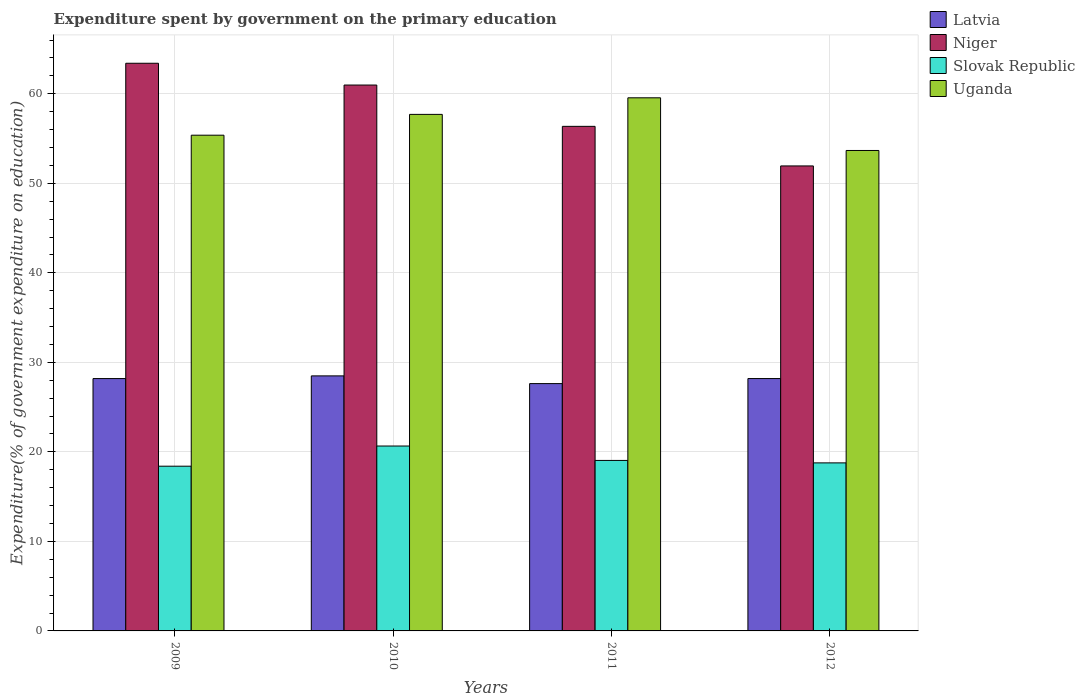How many groups of bars are there?
Give a very brief answer. 4. Are the number of bars per tick equal to the number of legend labels?
Your answer should be compact. Yes. Are the number of bars on each tick of the X-axis equal?
Your answer should be compact. Yes. How many bars are there on the 2nd tick from the left?
Offer a terse response. 4. What is the expenditure spent by government on the primary education in Niger in 2010?
Give a very brief answer. 60.98. Across all years, what is the maximum expenditure spent by government on the primary education in Latvia?
Give a very brief answer. 28.49. Across all years, what is the minimum expenditure spent by government on the primary education in Uganda?
Your response must be concise. 53.67. In which year was the expenditure spent by government on the primary education in Latvia maximum?
Keep it short and to the point. 2010. In which year was the expenditure spent by government on the primary education in Slovak Republic minimum?
Ensure brevity in your answer.  2009. What is the total expenditure spent by government on the primary education in Niger in the graph?
Your answer should be compact. 232.69. What is the difference between the expenditure spent by government on the primary education in Slovak Republic in 2011 and that in 2012?
Offer a terse response. 0.27. What is the difference between the expenditure spent by government on the primary education in Uganda in 2011 and the expenditure spent by government on the primary education in Latvia in 2009?
Provide a succinct answer. 31.36. What is the average expenditure spent by government on the primary education in Niger per year?
Your answer should be compact. 58.17. In the year 2010, what is the difference between the expenditure spent by government on the primary education in Uganda and expenditure spent by government on the primary education in Niger?
Your answer should be very brief. -3.28. What is the ratio of the expenditure spent by government on the primary education in Niger in 2009 to that in 2010?
Provide a short and direct response. 1.04. Is the difference between the expenditure spent by government on the primary education in Uganda in 2009 and 2011 greater than the difference between the expenditure spent by government on the primary education in Niger in 2009 and 2011?
Make the answer very short. No. What is the difference between the highest and the second highest expenditure spent by government on the primary education in Latvia?
Your answer should be very brief. 0.3. What is the difference between the highest and the lowest expenditure spent by government on the primary education in Niger?
Provide a short and direct response. 11.47. In how many years, is the expenditure spent by government on the primary education in Niger greater than the average expenditure spent by government on the primary education in Niger taken over all years?
Provide a short and direct response. 2. Is the sum of the expenditure spent by government on the primary education in Latvia in 2009 and 2012 greater than the maximum expenditure spent by government on the primary education in Uganda across all years?
Make the answer very short. No. What does the 3rd bar from the left in 2010 represents?
Ensure brevity in your answer.  Slovak Republic. What does the 3rd bar from the right in 2009 represents?
Ensure brevity in your answer.  Niger. How many bars are there?
Your answer should be very brief. 16. How many years are there in the graph?
Your answer should be very brief. 4. Are the values on the major ticks of Y-axis written in scientific E-notation?
Offer a very short reply. No. Where does the legend appear in the graph?
Make the answer very short. Top right. How many legend labels are there?
Offer a very short reply. 4. How are the legend labels stacked?
Your answer should be very brief. Vertical. What is the title of the graph?
Provide a short and direct response. Expenditure spent by government on the primary education. What is the label or title of the Y-axis?
Your response must be concise. Expenditure(% of government expenditure on education). What is the Expenditure(% of government expenditure on education) of Latvia in 2009?
Make the answer very short. 28.19. What is the Expenditure(% of government expenditure on education) in Niger in 2009?
Keep it short and to the point. 63.41. What is the Expenditure(% of government expenditure on education) in Slovak Republic in 2009?
Keep it short and to the point. 18.4. What is the Expenditure(% of government expenditure on education) of Uganda in 2009?
Your answer should be very brief. 55.38. What is the Expenditure(% of government expenditure on education) of Latvia in 2010?
Your answer should be compact. 28.49. What is the Expenditure(% of government expenditure on education) in Niger in 2010?
Ensure brevity in your answer.  60.98. What is the Expenditure(% of government expenditure on education) in Slovak Republic in 2010?
Make the answer very short. 20.65. What is the Expenditure(% of government expenditure on education) of Uganda in 2010?
Offer a terse response. 57.7. What is the Expenditure(% of government expenditure on education) in Latvia in 2011?
Provide a succinct answer. 27.63. What is the Expenditure(% of government expenditure on education) in Niger in 2011?
Give a very brief answer. 56.36. What is the Expenditure(% of government expenditure on education) in Slovak Republic in 2011?
Your answer should be very brief. 19.05. What is the Expenditure(% of government expenditure on education) in Uganda in 2011?
Ensure brevity in your answer.  59.55. What is the Expenditure(% of government expenditure on education) in Latvia in 2012?
Your answer should be compact. 28.19. What is the Expenditure(% of government expenditure on education) in Niger in 2012?
Your answer should be compact. 51.94. What is the Expenditure(% of government expenditure on education) in Slovak Republic in 2012?
Your answer should be compact. 18.77. What is the Expenditure(% of government expenditure on education) of Uganda in 2012?
Give a very brief answer. 53.67. Across all years, what is the maximum Expenditure(% of government expenditure on education) of Latvia?
Ensure brevity in your answer.  28.49. Across all years, what is the maximum Expenditure(% of government expenditure on education) in Niger?
Provide a succinct answer. 63.41. Across all years, what is the maximum Expenditure(% of government expenditure on education) of Slovak Republic?
Provide a short and direct response. 20.65. Across all years, what is the maximum Expenditure(% of government expenditure on education) in Uganda?
Your answer should be very brief. 59.55. Across all years, what is the minimum Expenditure(% of government expenditure on education) in Latvia?
Your response must be concise. 27.63. Across all years, what is the minimum Expenditure(% of government expenditure on education) of Niger?
Make the answer very short. 51.94. Across all years, what is the minimum Expenditure(% of government expenditure on education) of Slovak Republic?
Your answer should be very brief. 18.4. Across all years, what is the minimum Expenditure(% of government expenditure on education) of Uganda?
Your answer should be compact. 53.67. What is the total Expenditure(% of government expenditure on education) in Latvia in the graph?
Ensure brevity in your answer.  112.5. What is the total Expenditure(% of government expenditure on education) in Niger in the graph?
Give a very brief answer. 232.69. What is the total Expenditure(% of government expenditure on education) in Slovak Republic in the graph?
Your answer should be very brief. 76.87. What is the total Expenditure(% of government expenditure on education) of Uganda in the graph?
Your response must be concise. 226.3. What is the difference between the Expenditure(% of government expenditure on education) of Niger in 2009 and that in 2010?
Ensure brevity in your answer.  2.43. What is the difference between the Expenditure(% of government expenditure on education) of Slovak Republic in 2009 and that in 2010?
Keep it short and to the point. -2.25. What is the difference between the Expenditure(% of government expenditure on education) in Uganda in 2009 and that in 2010?
Provide a short and direct response. -2.33. What is the difference between the Expenditure(% of government expenditure on education) of Latvia in 2009 and that in 2011?
Your response must be concise. 0.56. What is the difference between the Expenditure(% of government expenditure on education) in Niger in 2009 and that in 2011?
Give a very brief answer. 7.05. What is the difference between the Expenditure(% of government expenditure on education) in Slovak Republic in 2009 and that in 2011?
Provide a short and direct response. -0.65. What is the difference between the Expenditure(% of government expenditure on education) of Uganda in 2009 and that in 2011?
Provide a short and direct response. -4.18. What is the difference between the Expenditure(% of government expenditure on education) of Latvia in 2009 and that in 2012?
Offer a very short reply. -0. What is the difference between the Expenditure(% of government expenditure on education) in Niger in 2009 and that in 2012?
Provide a short and direct response. 11.47. What is the difference between the Expenditure(% of government expenditure on education) in Slovak Republic in 2009 and that in 2012?
Provide a succinct answer. -0.37. What is the difference between the Expenditure(% of government expenditure on education) of Uganda in 2009 and that in 2012?
Give a very brief answer. 1.71. What is the difference between the Expenditure(% of government expenditure on education) of Latvia in 2010 and that in 2011?
Provide a succinct answer. 0.86. What is the difference between the Expenditure(% of government expenditure on education) of Niger in 2010 and that in 2011?
Offer a very short reply. 4.62. What is the difference between the Expenditure(% of government expenditure on education) of Slovak Republic in 2010 and that in 2011?
Your answer should be very brief. 1.61. What is the difference between the Expenditure(% of government expenditure on education) in Uganda in 2010 and that in 2011?
Provide a succinct answer. -1.85. What is the difference between the Expenditure(% of government expenditure on education) of Latvia in 2010 and that in 2012?
Provide a short and direct response. 0.3. What is the difference between the Expenditure(% of government expenditure on education) in Niger in 2010 and that in 2012?
Give a very brief answer. 9.04. What is the difference between the Expenditure(% of government expenditure on education) of Slovak Republic in 2010 and that in 2012?
Give a very brief answer. 1.88. What is the difference between the Expenditure(% of government expenditure on education) of Uganda in 2010 and that in 2012?
Provide a succinct answer. 4.03. What is the difference between the Expenditure(% of government expenditure on education) in Latvia in 2011 and that in 2012?
Your answer should be compact. -0.56. What is the difference between the Expenditure(% of government expenditure on education) of Niger in 2011 and that in 2012?
Offer a terse response. 4.42. What is the difference between the Expenditure(% of government expenditure on education) of Slovak Republic in 2011 and that in 2012?
Give a very brief answer. 0.27. What is the difference between the Expenditure(% of government expenditure on education) in Uganda in 2011 and that in 2012?
Provide a succinct answer. 5.88. What is the difference between the Expenditure(% of government expenditure on education) in Latvia in 2009 and the Expenditure(% of government expenditure on education) in Niger in 2010?
Ensure brevity in your answer.  -32.79. What is the difference between the Expenditure(% of government expenditure on education) of Latvia in 2009 and the Expenditure(% of government expenditure on education) of Slovak Republic in 2010?
Your response must be concise. 7.54. What is the difference between the Expenditure(% of government expenditure on education) of Latvia in 2009 and the Expenditure(% of government expenditure on education) of Uganda in 2010?
Keep it short and to the point. -29.51. What is the difference between the Expenditure(% of government expenditure on education) in Niger in 2009 and the Expenditure(% of government expenditure on education) in Slovak Republic in 2010?
Offer a very short reply. 42.76. What is the difference between the Expenditure(% of government expenditure on education) of Niger in 2009 and the Expenditure(% of government expenditure on education) of Uganda in 2010?
Your answer should be compact. 5.71. What is the difference between the Expenditure(% of government expenditure on education) of Slovak Republic in 2009 and the Expenditure(% of government expenditure on education) of Uganda in 2010?
Make the answer very short. -39.3. What is the difference between the Expenditure(% of government expenditure on education) in Latvia in 2009 and the Expenditure(% of government expenditure on education) in Niger in 2011?
Ensure brevity in your answer.  -28.17. What is the difference between the Expenditure(% of government expenditure on education) in Latvia in 2009 and the Expenditure(% of government expenditure on education) in Slovak Republic in 2011?
Your answer should be very brief. 9.14. What is the difference between the Expenditure(% of government expenditure on education) in Latvia in 2009 and the Expenditure(% of government expenditure on education) in Uganda in 2011?
Ensure brevity in your answer.  -31.36. What is the difference between the Expenditure(% of government expenditure on education) in Niger in 2009 and the Expenditure(% of government expenditure on education) in Slovak Republic in 2011?
Make the answer very short. 44.37. What is the difference between the Expenditure(% of government expenditure on education) of Niger in 2009 and the Expenditure(% of government expenditure on education) of Uganda in 2011?
Offer a very short reply. 3.86. What is the difference between the Expenditure(% of government expenditure on education) in Slovak Republic in 2009 and the Expenditure(% of government expenditure on education) in Uganda in 2011?
Make the answer very short. -41.15. What is the difference between the Expenditure(% of government expenditure on education) in Latvia in 2009 and the Expenditure(% of government expenditure on education) in Niger in 2012?
Give a very brief answer. -23.75. What is the difference between the Expenditure(% of government expenditure on education) in Latvia in 2009 and the Expenditure(% of government expenditure on education) in Slovak Republic in 2012?
Ensure brevity in your answer.  9.42. What is the difference between the Expenditure(% of government expenditure on education) of Latvia in 2009 and the Expenditure(% of government expenditure on education) of Uganda in 2012?
Your response must be concise. -25.48. What is the difference between the Expenditure(% of government expenditure on education) in Niger in 2009 and the Expenditure(% of government expenditure on education) in Slovak Republic in 2012?
Your answer should be very brief. 44.64. What is the difference between the Expenditure(% of government expenditure on education) of Niger in 2009 and the Expenditure(% of government expenditure on education) of Uganda in 2012?
Give a very brief answer. 9.74. What is the difference between the Expenditure(% of government expenditure on education) in Slovak Republic in 2009 and the Expenditure(% of government expenditure on education) in Uganda in 2012?
Give a very brief answer. -35.27. What is the difference between the Expenditure(% of government expenditure on education) of Latvia in 2010 and the Expenditure(% of government expenditure on education) of Niger in 2011?
Your answer should be very brief. -27.87. What is the difference between the Expenditure(% of government expenditure on education) in Latvia in 2010 and the Expenditure(% of government expenditure on education) in Slovak Republic in 2011?
Provide a succinct answer. 9.44. What is the difference between the Expenditure(% of government expenditure on education) of Latvia in 2010 and the Expenditure(% of government expenditure on education) of Uganda in 2011?
Offer a terse response. -31.06. What is the difference between the Expenditure(% of government expenditure on education) in Niger in 2010 and the Expenditure(% of government expenditure on education) in Slovak Republic in 2011?
Ensure brevity in your answer.  41.93. What is the difference between the Expenditure(% of government expenditure on education) in Niger in 2010 and the Expenditure(% of government expenditure on education) in Uganda in 2011?
Your response must be concise. 1.43. What is the difference between the Expenditure(% of government expenditure on education) in Slovak Republic in 2010 and the Expenditure(% of government expenditure on education) in Uganda in 2011?
Provide a succinct answer. -38.9. What is the difference between the Expenditure(% of government expenditure on education) of Latvia in 2010 and the Expenditure(% of government expenditure on education) of Niger in 2012?
Keep it short and to the point. -23.45. What is the difference between the Expenditure(% of government expenditure on education) in Latvia in 2010 and the Expenditure(% of government expenditure on education) in Slovak Republic in 2012?
Offer a terse response. 9.72. What is the difference between the Expenditure(% of government expenditure on education) in Latvia in 2010 and the Expenditure(% of government expenditure on education) in Uganda in 2012?
Offer a very short reply. -25.18. What is the difference between the Expenditure(% of government expenditure on education) of Niger in 2010 and the Expenditure(% of government expenditure on education) of Slovak Republic in 2012?
Give a very brief answer. 42.21. What is the difference between the Expenditure(% of government expenditure on education) in Niger in 2010 and the Expenditure(% of government expenditure on education) in Uganda in 2012?
Your answer should be very brief. 7.31. What is the difference between the Expenditure(% of government expenditure on education) in Slovak Republic in 2010 and the Expenditure(% of government expenditure on education) in Uganda in 2012?
Offer a very short reply. -33.02. What is the difference between the Expenditure(% of government expenditure on education) in Latvia in 2011 and the Expenditure(% of government expenditure on education) in Niger in 2012?
Make the answer very short. -24.31. What is the difference between the Expenditure(% of government expenditure on education) of Latvia in 2011 and the Expenditure(% of government expenditure on education) of Slovak Republic in 2012?
Offer a very short reply. 8.86. What is the difference between the Expenditure(% of government expenditure on education) in Latvia in 2011 and the Expenditure(% of government expenditure on education) in Uganda in 2012?
Provide a succinct answer. -26.04. What is the difference between the Expenditure(% of government expenditure on education) of Niger in 2011 and the Expenditure(% of government expenditure on education) of Slovak Republic in 2012?
Your answer should be very brief. 37.59. What is the difference between the Expenditure(% of government expenditure on education) of Niger in 2011 and the Expenditure(% of government expenditure on education) of Uganda in 2012?
Provide a succinct answer. 2.69. What is the difference between the Expenditure(% of government expenditure on education) in Slovak Republic in 2011 and the Expenditure(% of government expenditure on education) in Uganda in 2012?
Your answer should be compact. -34.62. What is the average Expenditure(% of government expenditure on education) in Latvia per year?
Ensure brevity in your answer.  28.12. What is the average Expenditure(% of government expenditure on education) of Niger per year?
Provide a succinct answer. 58.17. What is the average Expenditure(% of government expenditure on education) in Slovak Republic per year?
Keep it short and to the point. 19.22. What is the average Expenditure(% of government expenditure on education) in Uganda per year?
Make the answer very short. 56.57. In the year 2009, what is the difference between the Expenditure(% of government expenditure on education) in Latvia and Expenditure(% of government expenditure on education) in Niger?
Provide a succinct answer. -35.22. In the year 2009, what is the difference between the Expenditure(% of government expenditure on education) in Latvia and Expenditure(% of government expenditure on education) in Slovak Republic?
Make the answer very short. 9.79. In the year 2009, what is the difference between the Expenditure(% of government expenditure on education) in Latvia and Expenditure(% of government expenditure on education) in Uganda?
Your response must be concise. -27.19. In the year 2009, what is the difference between the Expenditure(% of government expenditure on education) of Niger and Expenditure(% of government expenditure on education) of Slovak Republic?
Your response must be concise. 45.01. In the year 2009, what is the difference between the Expenditure(% of government expenditure on education) in Niger and Expenditure(% of government expenditure on education) in Uganda?
Ensure brevity in your answer.  8.04. In the year 2009, what is the difference between the Expenditure(% of government expenditure on education) of Slovak Republic and Expenditure(% of government expenditure on education) of Uganda?
Ensure brevity in your answer.  -36.97. In the year 2010, what is the difference between the Expenditure(% of government expenditure on education) of Latvia and Expenditure(% of government expenditure on education) of Niger?
Your answer should be compact. -32.49. In the year 2010, what is the difference between the Expenditure(% of government expenditure on education) in Latvia and Expenditure(% of government expenditure on education) in Slovak Republic?
Offer a terse response. 7.84. In the year 2010, what is the difference between the Expenditure(% of government expenditure on education) in Latvia and Expenditure(% of government expenditure on education) in Uganda?
Provide a succinct answer. -29.21. In the year 2010, what is the difference between the Expenditure(% of government expenditure on education) in Niger and Expenditure(% of government expenditure on education) in Slovak Republic?
Ensure brevity in your answer.  40.32. In the year 2010, what is the difference between the Expenditure(% of government expenditure on education) of Niger and Expenditure(% of government expenditure on education) of Uganda?
Your answer should be very brief. 3.28. In the year 2010, what is the difference between the Expenditure(% of government expenditure on education) of Slovak Republic and Expenditure(% of government expenditure on education) of Uganda?
Offer a terse response. -37.05. In the year 2011, what is the difference between the Expenditure(% of government expenditure on education) of Latvia and Expenditure(% of government expenditure on education) of Niger?
Keep it short and to the point. -28.73. In the year 2011, what is the difference between the Expenditure(% of government expenditure on education) in Latvia and Expenditure(% of government expenditure on education) in Slovak Republic?
Your answer should be compact. 8.58. In the year 2011, what is the difference between the Expenditure(% of government expenditure on education) of Latvia and Expenditure(% of government expenditure on education) of Uganda?
Your response must be concise. -31.92. In the year 2011, what is the difference between the Expenditure(% of government expenditure on education) in Niger and Expenditure(% of government expenditure on education) in Slovak Republic?
Make the answer very short. 37.32. In the year 2011, what is the difference between the Expenditure(% of government expenditure on education) of Niger and Expenditure(% of government expenditure on education) of Uganda?
Ensure brevity in your answer.  -3.19. In the year 2011, what is the difference between the Expenditure(% of government expenditure on education) of Slovak Republic and Expenditure(% of government expenditure on education) of Uganda?
Offer a terse response. -40.51. In the year 2012, what is the difference between the Expenditure(% of government expenditure on education) in Latvia and Expenditure(% of government expenditure on education) in Niger?
Keep it short and to the point. -23.75. In the year 2012, what is the difference between the Expenditure(% of government expenditure on education) of Latvia and Expenditure(% of government expenditure on education) of Slovak Republic?
Your answer should be compact. 9.42. In the year 2012, what is the difference between the Expenditure(% of government expenditure on education) in Latvia and Expenditure(% of government expenditure on education) in Uganda?
Keep it short and to the point. -25.48. In the year 2012, what is the difference between the Expenditure(% of government expenditure on education) in Niger and Expenditure(% of government expenditure on education) in Slovak Republic?
Ensure brevity in your answer.  33.17. In the year 2012, what is the difference between the Expenditure(% of government expenditure on education) in Niger and Expenditure(% of government expenditure on education) in Uganda?
Your response must be concise. -1.73. In the year 2012, what is the difference between the Expenditure(% of government expenditure on education) in Slovak Republic and Expenditure(% of government expenditure on education) in Uganda?
Give a very brief answer. -34.9. What is the ratio of the Expenditure(% of government expenditure on education) of Niger in 2009 to that in 2010?
Offer a terse response. 1.04. What is the ratio of the Expenditure(% of government expenditure on education) of Slovak Republic in 2009 to that in 2010?
Provide a succinct answer. 0.89. What is the ratio of the Expenditure(% of government expenditure on education) of Uganda in 2009 to that in 2010?
Give a very brief answer. 0.96. What is the ratio of the Expenditure(% of government expenditure on education) in Latvia in 2009 to that in 2011?
Provide a short and direct response. 1.02. What is the ratio of the Expenditure(% of government expenditure on education) in Niger in 2009 to that in 2011?
Give a very brief answer. 1.13. What is the ratio of the Expenditure(% of government expenditure on education) in Slovak Republic in 2009 to that in 2011?
Offer a terse response. 0.97. What is the ratio of the Expenditure(% of government expenditure on education) of Uganda in 2009 to that in 2011?
Ensure brevity in your answer.  0.93. What is the ratio of the Expenditure(% of government expenditure on education) in Latvia in 2009 to that in 2012?
Your answer should be compact. 1. What is the ratio of the Expenditure(% of government expenditure on education) in Niger in 2009 to that in 2012?
Give a very brief answer. 1.22. What is the ratio of the Expenditure(% of government expenditure on education) in Slovak Republic in 2009 to that in 2012?
Provide a short and direct response. 0.98. What is the ratio of the Expenditure(% of government expenditure on education) of Uganda in 2009 to that in 2012?
Make the answer very short. 1.03. What is the ratio of the Expenditure(% of government expenditure on education) of Latvia in 2010 to that in 2011?
Offer a very short reply. 1.03. What is the ratio of the Expenditure(% of government expenditure on education) in Niger in 2010 to that in 2011?
Your answer should be very brief. 1.08. What is the ratio of the Expenditure(% of government expenditure on education) of Slovak Republic in 2010 to that in 2011?
Provide a succinct answer. 1.08. What is the ratio of the Expenditure(% of government expenditure on education) of Uganda in 2010 to that in 2011?
Give a very brief answer. 0.97. What is the ratio of the Expenditure(% of government expenditure on education) of Latvia in 2010 to that in 2012?
Provide a short and direct response. 1.01. What is the ratio of the Expenditure(% of government expenditure on education) in Niger in 2010 to that in 2012?
Offer a terse response. 1.17. What is the ratio of the Expenditure(% of government expenditure on education) in Slovak Republic in 2010 to that in 2012?
Your answer should be very brief. 1.1. What is the ratio of the Expenditure(% of government expenditure on education) in Uganda in 2010 to that in 2012?
Provide a succinct answer. 1.08. What is the ratio of the Expenditure(% of government expenditure on education) in Latvia in 2011 to that in 2012?
Offer a very short reply. 0.98. What is the ratio of the Expenditure(% of government expenditure on education) of Niger in 2011 to that in 2012?
Ensure brevity in your answer.  1.09. What is the ratio of the Expenditure(% of government expenditure on education) in Slovak Republic in 2011 to that in 2012?
Offer a very short reply. 1.01. What is the ratio of the Expenditure(% of government expenditure on education) in Uganda in 2011 to that in 2012?
Ensure brevity in your answer.  1.11. What is the difference between the highest and the second highest Expenditure(% of government expenditure on education) in Latvia?
Your response must be concise. 0.3. What is the difference between the highest and the second highest Expenditure(% of government expenditure on education) of Niger?
Offer a terse response. 2.43. What is the difference between the highest and the second highest Expenditure(% of government expenditure on education) of Slovak Republic?
Your answer should be compact. 1.61. What is the difference between the highest and the second highest Expenditure(% of government expenditure on education) in Uganda?
Offer a very short reply. 1.85. What is the difference between the highest and the lowest Expenditure(% of government expenditure on education) in Latvia?
Give a very brief answer. 0.86. What is the difference between the highest and the lowest Expenditure(% of government expenditure on education) of Niger?
Your answer should be very brief. 11.47. What is the difference between the highest and the lowest Expenditure(% of government expenditure on education) in Slovak Republic?
Your answer should be compact. 2.25. What is the difference between the highest and the lowest Expenditure(% of government expenditure on education) in Uganda?
Your response must be concise. 5.88. 